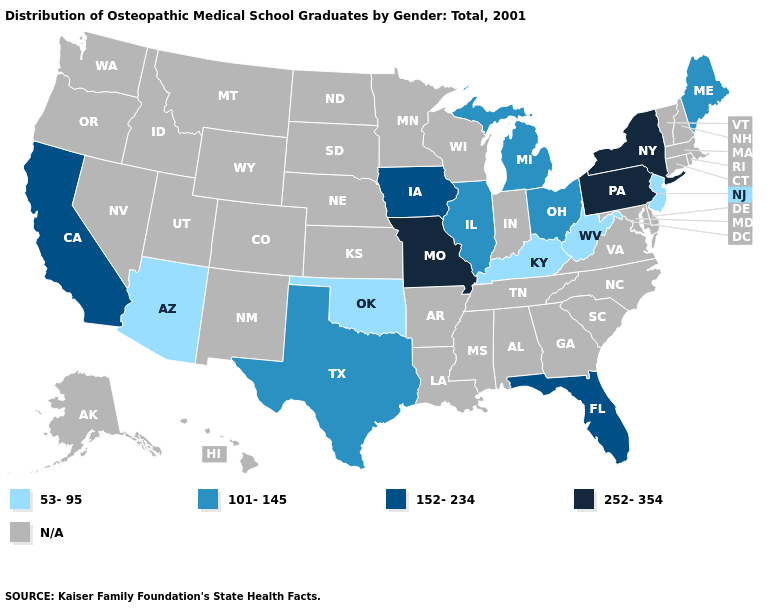What is the value of Oklahoma?
Be succinct. 53-95. Name the states that have a value in the range 101-145?
Give a very brief answer. Illinois, Maine, Michigan, Ohio, Texas. What is the value of Massachusetts?
Give a very brief answer. N/A. What is the highest value in the MidWest ?
Keep it brief. 252-354. What is the value of Illinois?
Quick response, please. 101-145. What is the value of Michigan?
Short answer required. 101-145. Name the states that have a value in the range 152-234?
Quick response, please. California, Florida, Iowa. Does Kentucky have the lowest value in the USA?
Concise answer only. Yes. What is the value of Colorado?
Keep it brief. N/A. Name the states that have a value in the range N/A?
Give a very brief answer. Alabama, Alaska, Arkansas, Colorado, Connecticut, Delaware, Georgia, Hawaii, Idaho, Indiana, Kansas, Louisiana, Maryland, Massachusetts, Minnesota, Mississippi, Montana, Nebraska, Nevada, New Hampshire, New Mexico, North Carolina, North Dakota, Oregon, Rhode Island, South Carolina, South Dakota, Tennessee, Utah, Vermont, Virginia, Washington, Wisconsin, Wyoming. Is the legend a continuous bar?
Short answer required. No. What is the value of Arkansas?
Concise answer only. N/A. What is the highest value in the USA?
Write a very short answer. 252-354. Does Missouri have the highest value in the MidWest?
Give a very brief answer. Yes. 